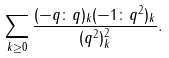<formula> <loc_0><loc_0><loc_500><loc_500>\sum _ { k \geq 0 } \frac { ( - q \colon q ) _ { k } ( - 1 \colon q ^ { 2 } ) _ { k } } { ( q ^ { 2 } ) ^ { 2 } _ { k } } .</formula> 